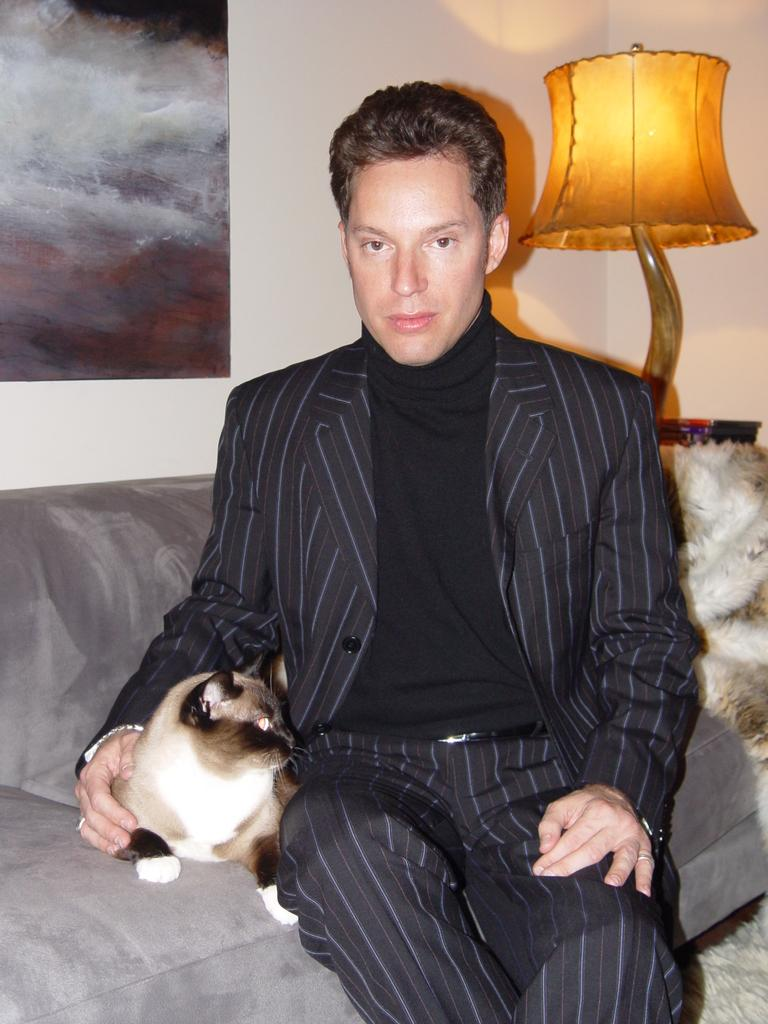Who or what is present in the image? There is a person in the image. What is the person wearing? The person is wearing a black and white dress. Where is the person sitting? The person is sitting on a sofa. What else is on the sofa? There is a cat on the sofa. What is located behind the sofa? There is a lamp behind the sofa. What can be seen on the wall? There is a poster on the wall. What type of sock is the person wearing in the image? There is no sock visible in the image; the person is wearing a dress. 